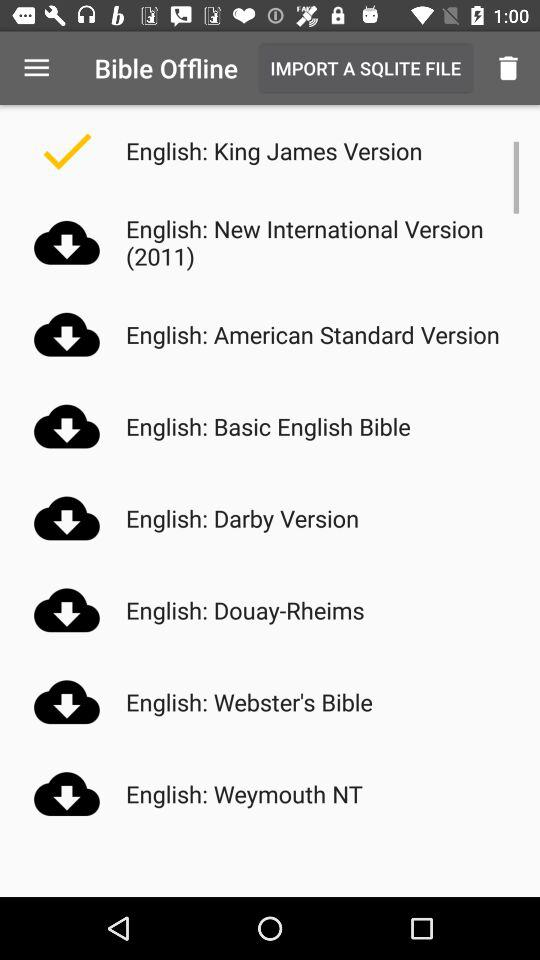How many English versions of the Bible are available?
Answer the question using a single word or phrase. 8 